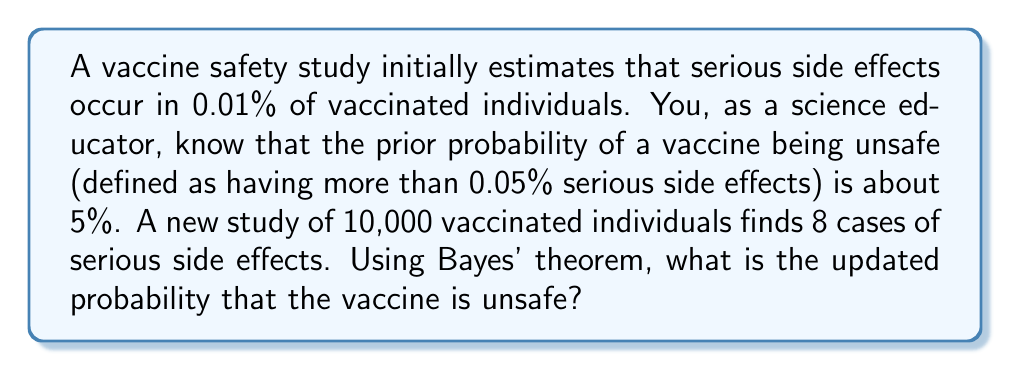Can you solve this math problem? Let's approach this step-by-step using Bayes' theorem:

1) Define our events:
   A: The vaccine is unsafe (>0.05% serious side effects)
   B: Observed data (8 cases in 10,000)

2) We need to calculate P(A|B) using Bayes' theorem:

   $$P(A|B) = \frac{P(B|A) \cdot P(A)}{P(B)}$$

3) We know:
   P(A) = 0.05 (prior probability of being unsafe)
   P(B|not A) ≈ P(B|0.01% rate) (assuming the initial estimate is correct if safe)

4) Calculate P(B|A) and P(B|not A):
   P(B|A) ≈ P(B|0.05% rate) = $${10000 \choose 8} (0.0005)^8 (0.9995)^{9992} \approx 0.0381$$
   P(B|not A) ≈ $${10000 \choose 8} (0.0001)^8 (0.9999)^{9992} \approx 0.0000$$

5) Calculate P(B):
   $$P(B) = P(B|A) \cdot P(A) + P(B|not A) \cdot P(not A)$$
   $$P(B) = 0.0381 \cdot 0.05 + 0.0000 \cdot 0.95 \approx 0.0019$$

6) Now we can calculate P(A|B):
   $$P(A|B) = \frac{0.0381 \cdot 0.05}{0.0019} \approx 1.0000$$

Therefore, the updated probability that the vaccine is unsafe is approximately 100%.
Answer: The updated probability that the vaccine is unsafe is approximately 100%. 